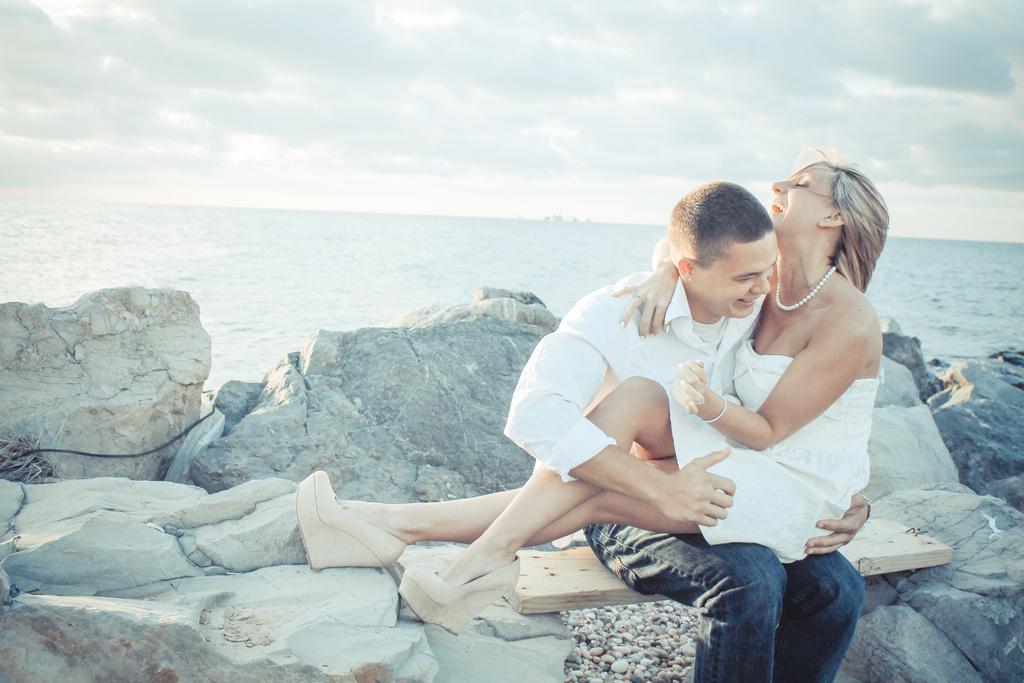Could you give a brief overview of what you see in this image? In this picture I can see a person sitting on the wooden surface which is placed on the rocks and holding a woman, behind there are some water. 